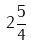<formula> <loc_0><loc_0><loc_500><loc_500>2 \frac { 5 } { 4 }</formula> 